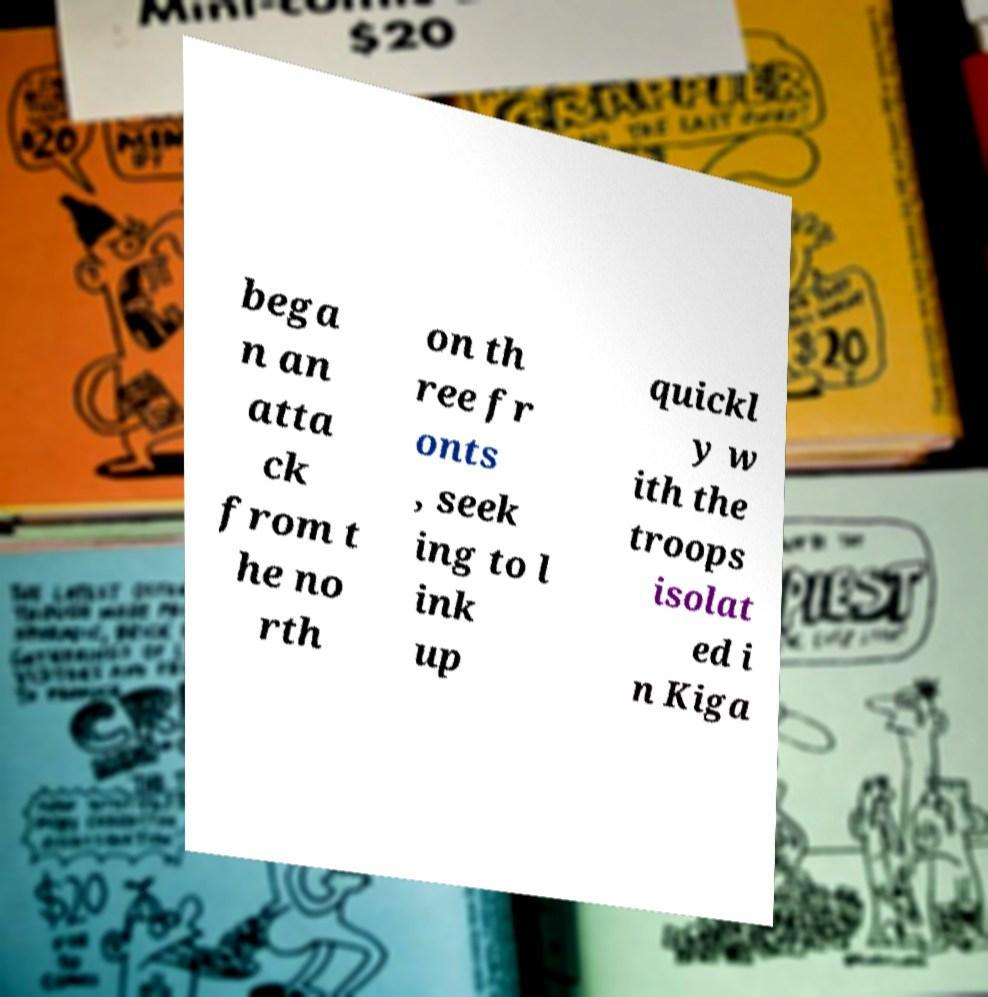Could you extract and type out the text from this image? bega n an atta ck from t he no rth on th ree fr onts , seek ing to l ink up quickl y w ith the troops isolat ed i n Kiga 